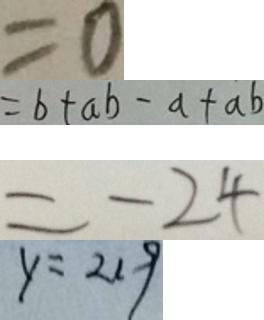<formula> <loc_0><loc_0><loc_500><loc_500>= 0 
 = b + a b - a + a b 
 = - 2 4 
 y = 2 1 9</formula> 